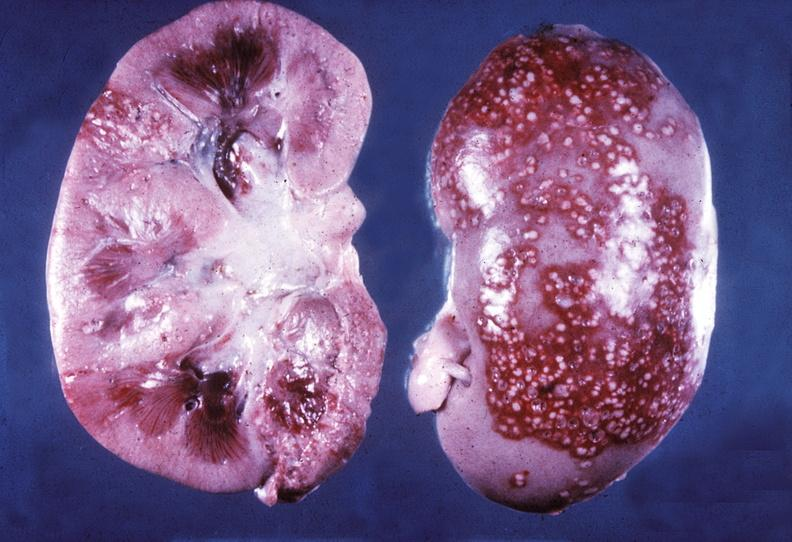does this image show kidney, pyelonephritis, acute?
Answer the question using a single word or phrase. Yes 